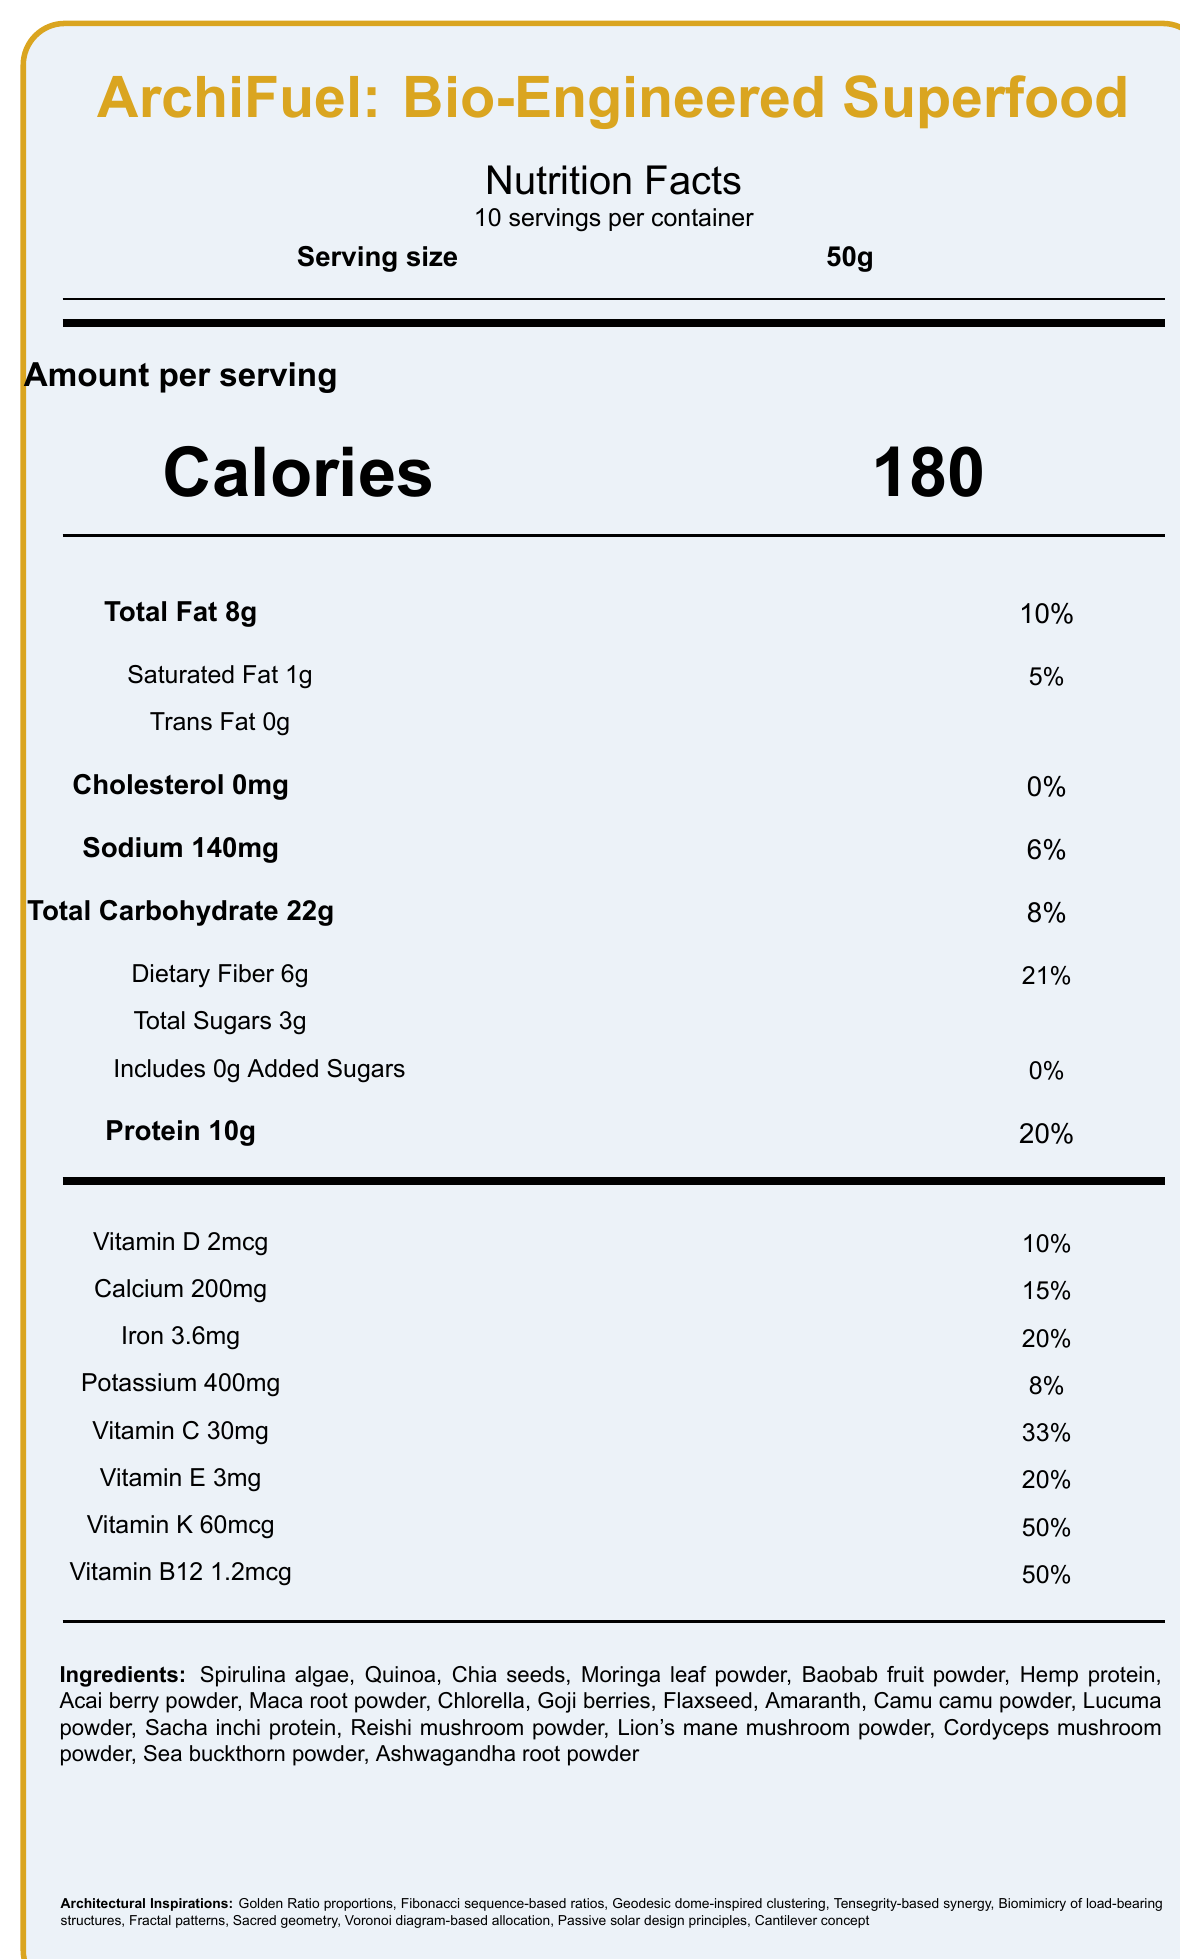what is the serving size? The document specifies the serving size as 50g.
Answer: 50g how many servings are in a container? The document states there are 10 servings per container.
Answer: 10 how many calories per serving? The document lists 180 calories per serving.
Answer: 180 what is the total fat content per serving? The document indicates that there are 8g of total fat per serving.
Answer: 8g what is the daily value percentage for sodium? According to the document, the daily value percentage for sodium is 6%.
Answer: 6% what is the amount of protein per serving? The document provides that there are 10g of protein per serving.
Answer: 10g what is the daily value percentage for vitamin D? The document shows that the daily value percentage for vitamin D is 10%.
Answer: 10% what ingredients are used in ArchiFuel: Bio-Engineered Superfood? The document lists these ingredients under the ingredients section.
Answer: Spirulina algae, Quinoa, Chia seeds, Moringa leaf powder, Baobab fruit powder, Hemp protein, Acai berry powder, Maca root powder, Chlorella, Goji berries, Flaxseed, Amaranth, Camu camu powder, Lucuma powder, Sacha inchi protein, Reishi mushroom powder, Lion's mane mushroom powder, Cordyceps mushroom powder, Sea buckthorn powder, Ashwagandha root powder which vitamin or mineral has the highest daily value percentage? A. Vitamin E B. Vitamin K C. Vitamin B12 D. Vitamin C Vitamin K has a daily value percentage of 50%, which is the highest among the listed vitamins and minerals.
Answer: B which architectural inspiration is not mentioned in the document? A. Golden Ratio proportions B. Fibonacci sequence-based ratios C. Roman aqueduct designs D. Geodesic dome-inspired clustering Roman aqueduct designs are not mentioned, whereas the other inspirations are listed in the document.
Answer: C does the product contain any added sugars? The document states that added sugars amount to 0g per serving.
Answer: No can we determine the exact amount of biotin present in the superfood? The document specifies that there is 10mcg of biotin with a daily value percentage of 33%.
Answer: Yes is the nutrient profile designed based on ancient architectural principles? The document mentions that the nutrient profile is inspired by ancient architectural principles such as the Golden Ratio, Fibonacci sequence, and more.
Answer: Yes is there any information about allergens in the document? The document does not provide any information regarding potential allergens.
Answer: Not enough information summarize the main idea of the document. The main idea of the document is to provide a comprehensive nutrient profile of the superfood, detailing its components and the unique architectural principles that inspired its creation.
Answer: The document presents the nutrition facts of "ArchiFuel: Bio-Engineered Superfood," including serving size, calories, macro and micronutrient content, and a list of ingredients. It also highlights the architectural inspirations and experimental features used in its formulation. 